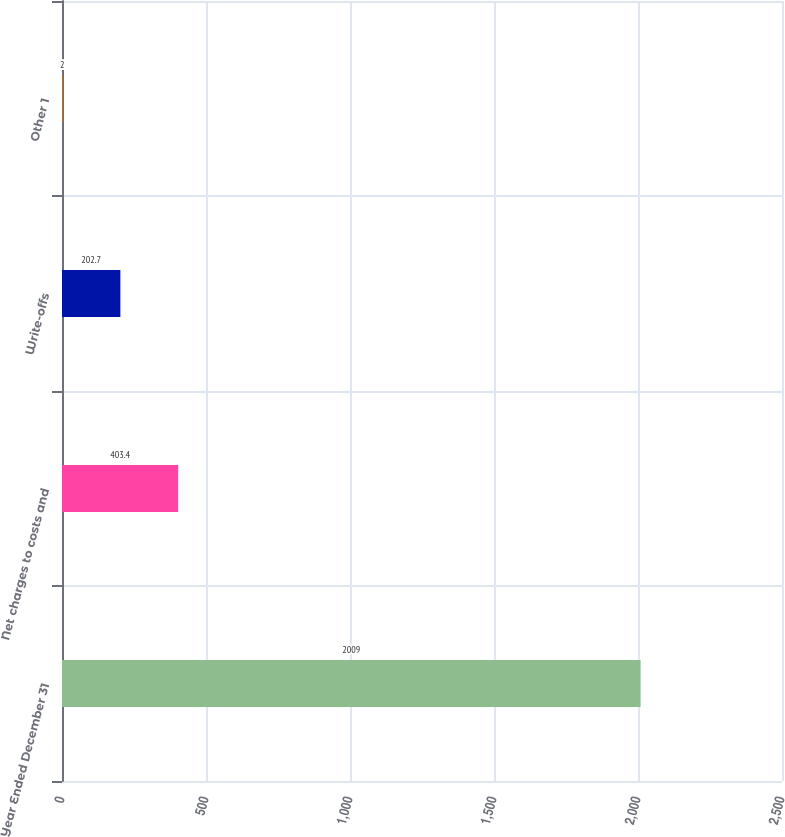Convert chart. <chart><loc_0><loc_0><loc_500><loc_500><bar_chart><fcel>Year Ended December 31<fcel>Net charges to costs and<fcel>Write-offs<fcel>Other 1<nl><fcel>2009<fcel>403.4<fcel>202.7<fcel>2<nl></chart> 